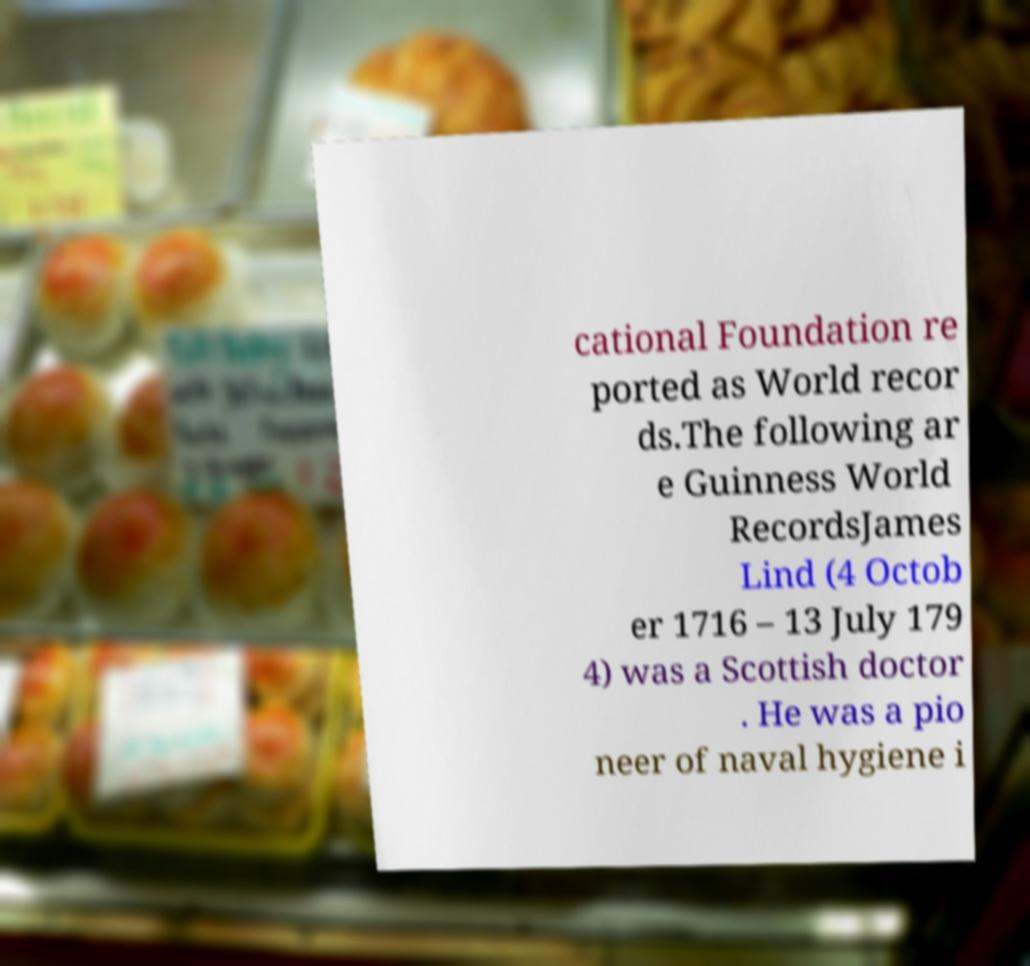For documentation purposes, I need the text within this image transcribed. Could you provide that? cational Foundation re ported as World recor ds.The following ar e Guinness World RecordsJames Lind (4 Octob er 1716 – 13 July 179 4) was a Scottish doctor . He was a pio neer of naval hygiene i 